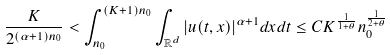<formula> <loc_0><loc_0><loc_500><loc_500>\frac { K } { 2 ^ { ( \alpha + 1 ) n _ { 0 } } } < \int _ { n _ { 0 } } ^ { ( K + 1 ) n _ { 0 } } \int _ { \mathbb { R } ^ { d } } | u ( t , x ) | ^ { \alpha + 1 } d x d t \leq C K ^ { \frac { 1 } { 1 + \theta } } n _ { 0 } ^ { \frac { 1 } { 2 + \theta } }</formula> 